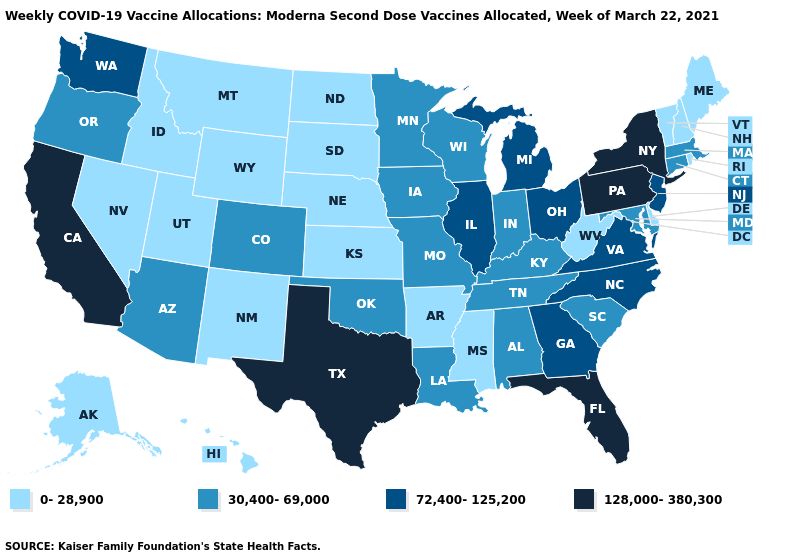What is the value of Missouri?
Be succinct. 30,400-69,000. What is the highest value in states that border Delaware?
Quick response, please. 128,000-380,300. What is the highest value in states that border Wyoming?
Give a very brief answer. 30,400-69,000. Among the states that border Tennessee , which have the lowest value?
Short answer required. Arkansas, Mississippi. Which states have the lowest value in the MidWest?
Be succinct. Kansas, Nebraska, North Dakota, South Dakota. Does Texas have the lowest value in the USA?
Give a very brief answer. No. Does California have the same value as New York?
Concise answer only. Yes. What is the value of Louisiana?
Answer briefly. 30,400-69,000. What is the value of Pennsylvania?
Give a very brief answer. 128,000-380,300. Does the map have missing data?
Be succinct. No. What is the value of Kentucky?
Short answer required. 30,400-69,000. Name the states that have a value in the range 0-28,900?
Short answer required. Alaska, Arkansas, Delaware, Hawaii, Idaho, Kansas, Maine, Mississippi, Montana, Nebraska, Nevada, New Hampshire, New Mexico, North Dakota, Rhode Island, South Dakota, Utah, Vermont, West Virginia, Wyoming. Does Maine have the same value as Arkansas?
Keep it brief. Yes. Which states have the lowest value in the Northeast?
Be succinct. Maine, New Hampshire, Rhode Island, Vermont. What is the lowest value in the West?
Short answer required. 0-28,900. 